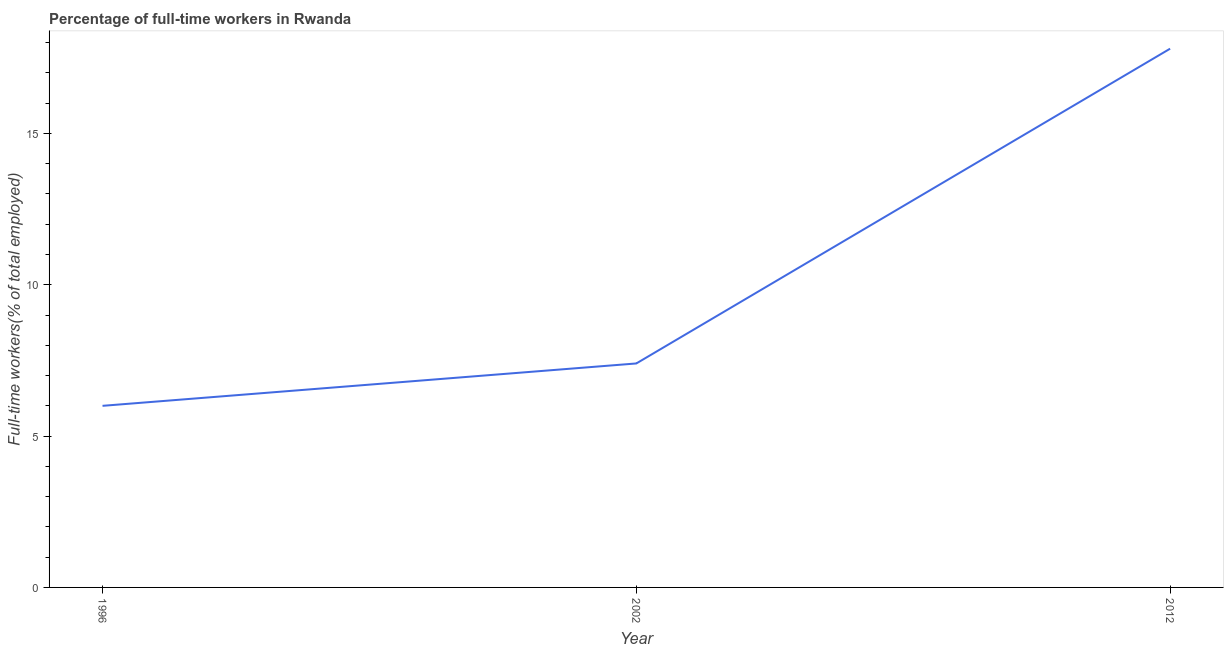What is the percentage of full-time workers in 2002?
Your answer should be very brief. 7.4. Across all years, what is the maximum percentage of full-time workers?
Offer a terse response. 17.8. In which year was the percentage of full-time workers maximum?
Make the answer very short. 2012. What is the sum of the percentage of full-time workers?
Keep it short and to the point. 31.2. What is the difference between the percentage of full-time workers in 1996 and 2002?
Ensure brevity in your answer.  -1.4. What is the average percentage of full-time workers per year?
Give a very brief answer. 10.4. What is the median percentage of full-time workers?
Your answer should be compact. 7.4. What is the ratio of the percentage of full-time workers in 1996 to that in 2002?
Your response must be concise. 0.81. Is the difference between the percentage of full-time workers in 1996 and 2012 greater than the difference between any two years?
Make the answer very short. Yes. What is the difference between the highest and the second highest percentage of full-time workers?
Ensure brevity in your answer.  10.4. What is the difference between the highest and the lowest percentage of full-time workers?
Make the answer very short. 11.8. How many lines are there?
Your answer should be compact. 1. Does the graph contain any zero values?
Give a very brief answer. No. What is the title of the graph?
Keep it short and to the point. Percentage of full-time workers in Rwanda. What is the label or title of the X-axis?
Your answer should be very brief. Year. What is the label or title of the Y-axis?
Offer a very short reply. Full-time workers(% of total employed). What is the Full-time workers(% of total employed) of 1996?
Your response must be concise. 6. What is the Full-time workers(% of total employed) of 2002?
Your answer should be compact. 7.4. What is the Full-time workers(% of total employed) of 2012?
Offer a terse response. 17.8. What is the difference between the Full-time workers(% of total employed) in 1996 and 2002?
Keep it short and to the point. -1.4. What is the difference between the Full-time workers(% of total employed) in 1996 and 2012?
Give a very brief answer. -11.8. What is the ratio of the Full-time workers(% of total employed) in 1996 to that in 2002?
Make the answer very short. 0.81. What is the ratio of the Full-time workers(% of total employed) in 1996 to that in 2012?
Keep it short and to the point. 0.34. What is the ratio of the Full-time workers(% of total employed) in 2002 to that in 2012?
Give a very brief answer. 0.42. 